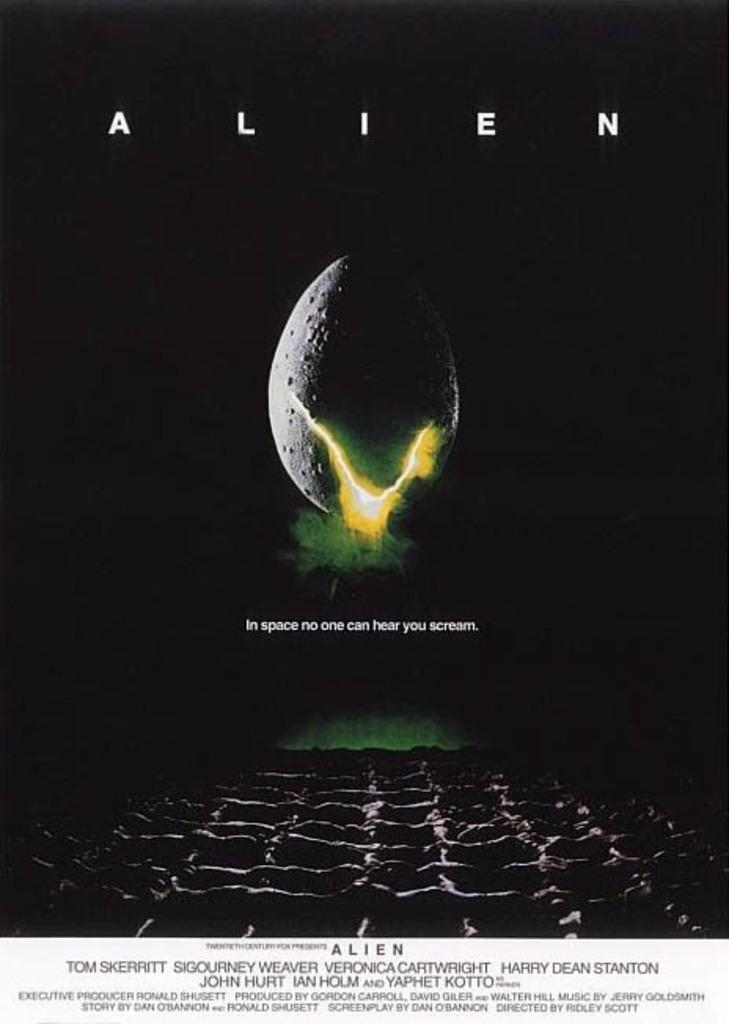Provide a one-sentence caption for the provided image. An advertising poster for the movie Alien which has a picture of an egg splitting and the slogan In space no one can hear you scream. 